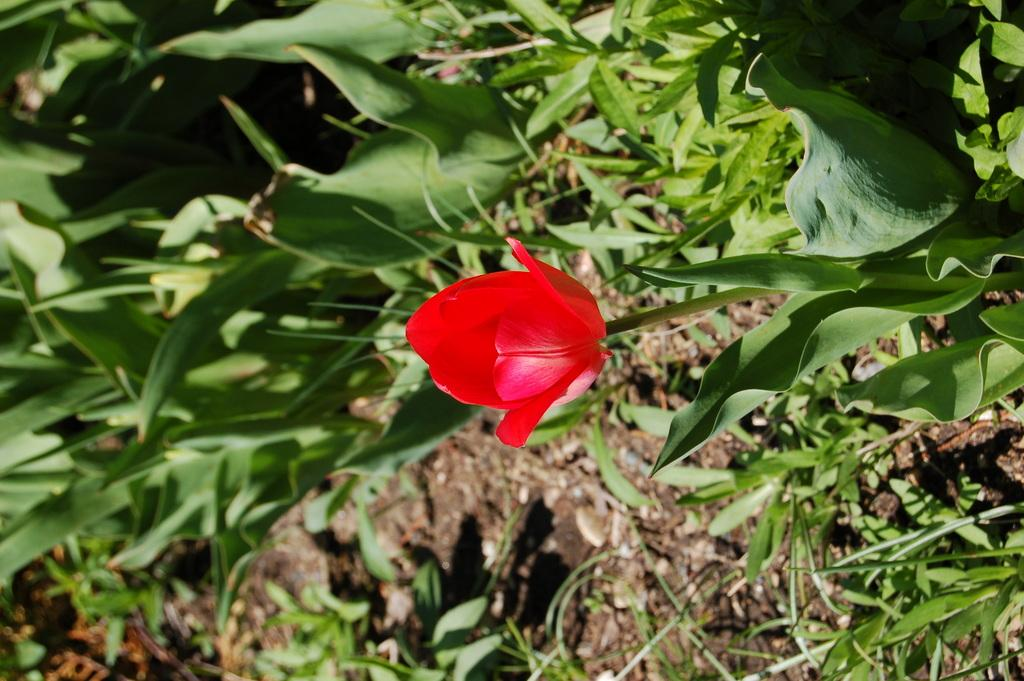What is covering the ground in the image? There are many plants on the ground in the image. Can you describe any specific features of the plants? There is a red color flower on a plant in the image. Where is the hose located in the image? There is no hose present in the image. What type of journey is depicted in the image? The image does not depict a journey; it features plants on the ground. 